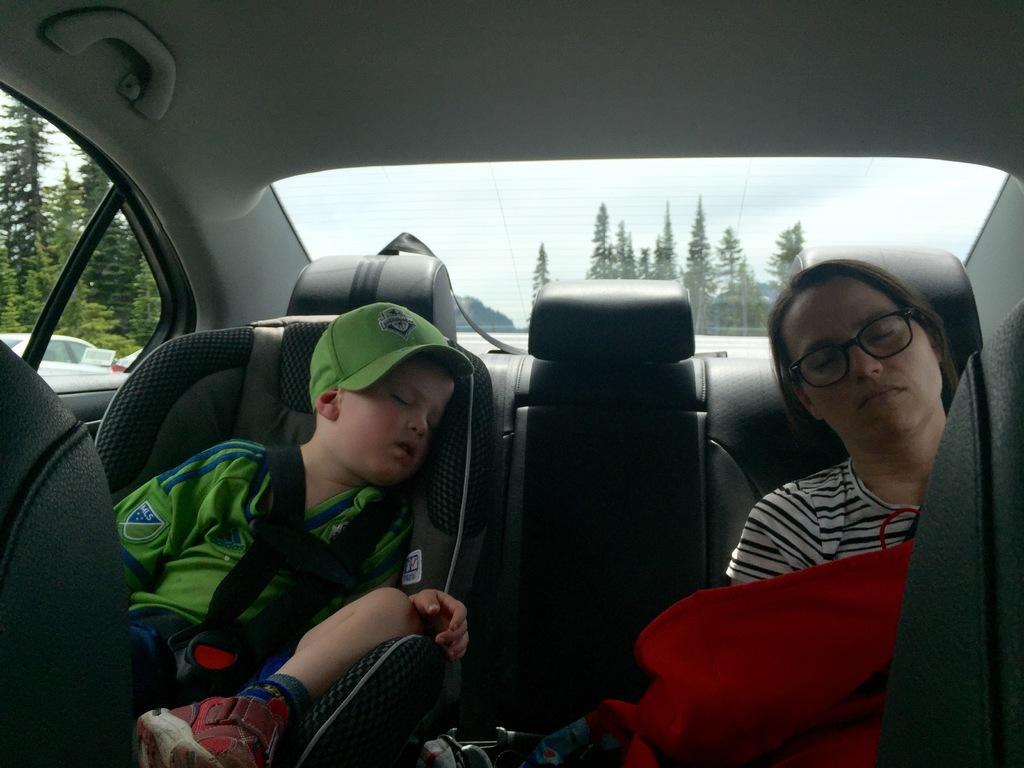Can you describe this image briefly? The image is taken in the car. There are two people sitting and sleeping in the car. In the background we can see trees and sky. 